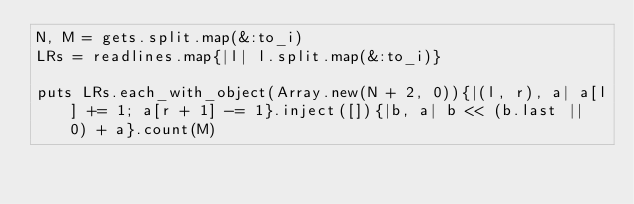<code> <loc_0><loc_0><loc_500><loc_500><_Ruby_>N, M = gets.split.map(&:to_i)
LRs = readlines.map{|l| l.split.map(&:to_i)}

puts LRs.each_with_object(Array.new(N + 2, 0)){|(l, r), a| a[l] += 1; a[r + 1] -= 1}.inject([]){|b, a| b << (b.last || 0) + a}.count(M)</code> 